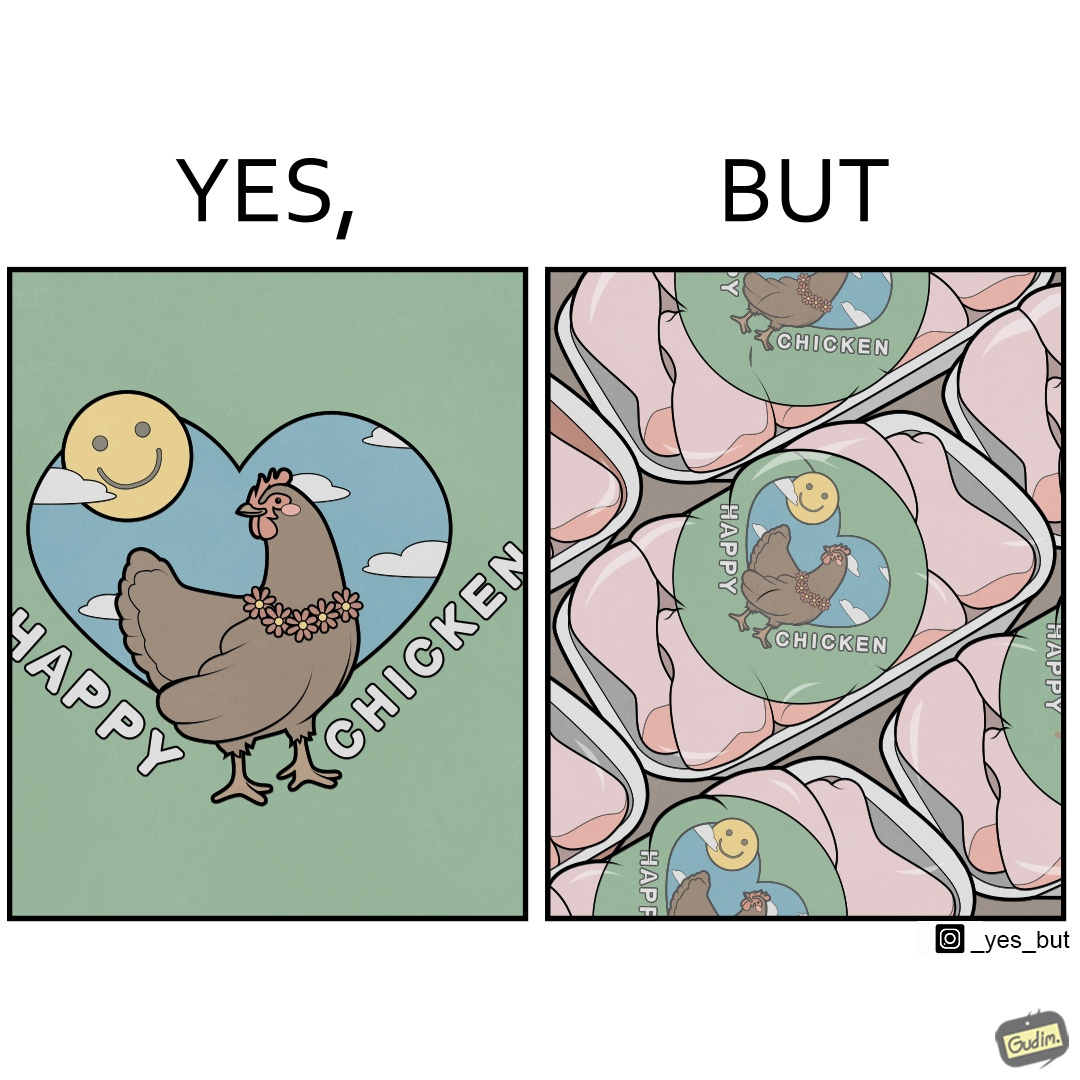Describe what you see in this image. The image is ironic, because in the left image as in the logo it shows happy chicken but in the right image the chicken pieces are shown packed in boxes 